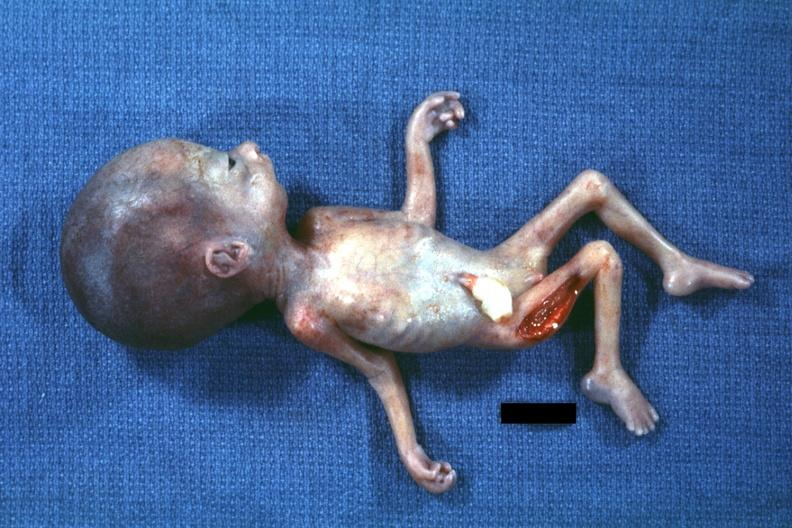s micrognathia triploid fetus present?
Answer the question using a single word or phrase. Yes 